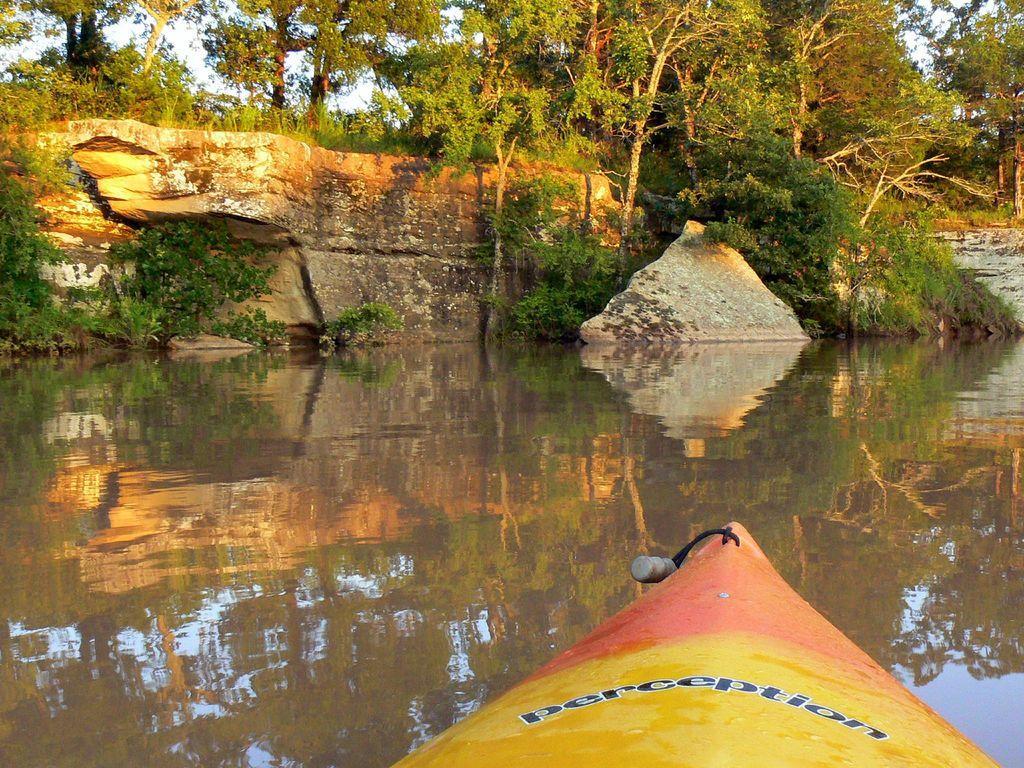How would you summarize this image in a sentence or two? In this image there is a boat on the water, in the background there rocks and trees. 